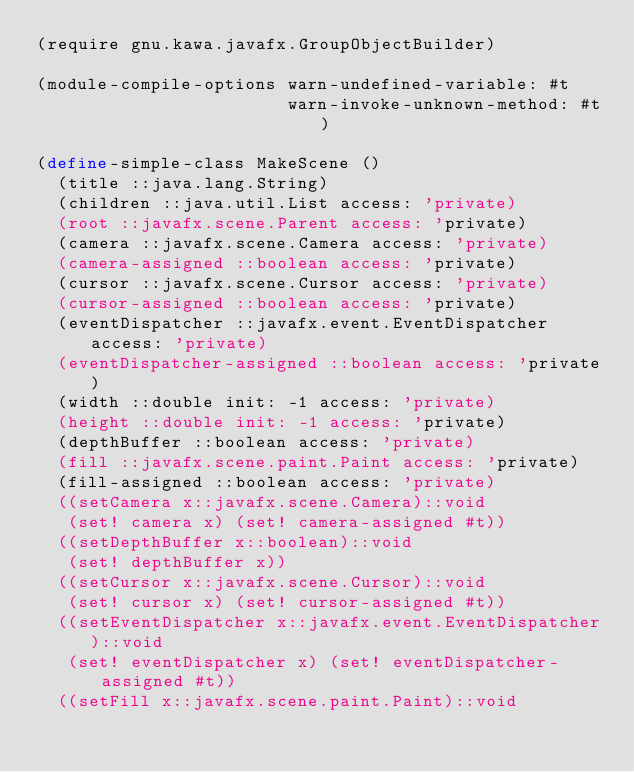<code> <loc_0><loc_0><loc_500><loc_500><_Scheme_>(require gnu.kawa.javafx.GroupObjectBuilder)

(module-compile-options warn-undefined-variable: #t
                        warn-invoke-unknown-method: #t)

(define-simple-class MakeScene ()
  (title ::java.lang.String)
  (children ::java.util.List access: 'private)
  (root ::javafx.scene.Parent access: 'private)
  (camera ::javafx.scene.Camera access: 'private)
  (camera-assigned ::boolean access: 'private)
  (cursor ::javafx.scene.Cursor access: 'private)
  (cursor-assigned ::boolean access: 'private)
  (eventDispatcher ::javafx.event.EventDispatcher access: 'private)
  (eventDispatcher-assigned ::boolean access: 'private)
  (width ::double init: -1 access: 'private)
  (height ::double init: -1 access: 'private)
  (depthBuffer ::boolean access: 'private)
  (fill ::javafx.scene.paint.Paint access: 'private)
  (fill-assigned ::boolean access: 'private)
  ((setCamera x::javafx.scene.Camera)::void
   (set! camera x) (set! camera-assigned #t))
  ((setDepthBuffer x::boolean)::void
   (set! depthBuffer x))
  ((setCursor x::javafx.scene.Cursor)::void
   (set! cursor x) (set! cursor-assigned #t))
  ((setEventDispatcher x::javafx.event.EventDispatcher)::void
   (set! eventDispatcher x) (set! eventDispatcher-assigned #t))
  ((setFill x::javafx.scene.paint.Paint)::void</code> 